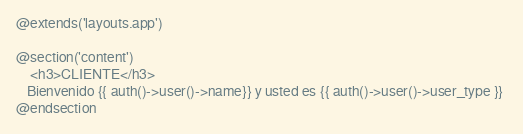Convert code to text. <code><loc_0><loc_0><loc_500><loc_500><_PHP_>@extends('layouts.app')

@section('content')
    <h3>CLIENTE</h3>
   Bienvenido {{ auth()->user()->name}} y usted es {{ auth()->user()->user_type }} 
@endsection</code> 